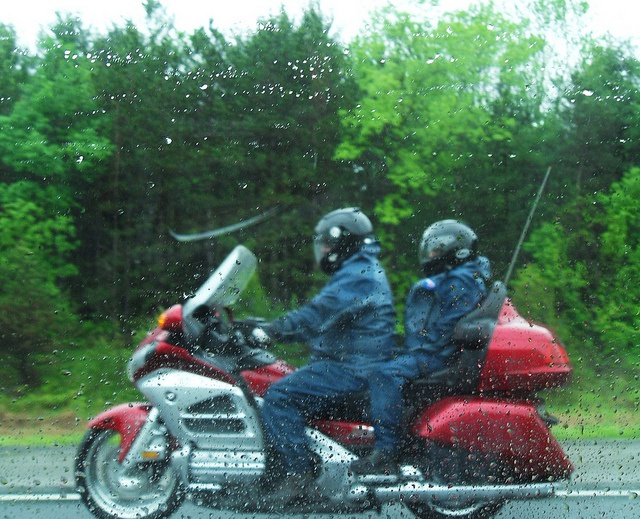Describe the objects in this image and their specific colors. I can see motorcycle in white, black, teal, and gray tones, people in white, blue, darkblue, black, and teal tones, and people in white, blue, darkblue, black, and teal tones in this image. 